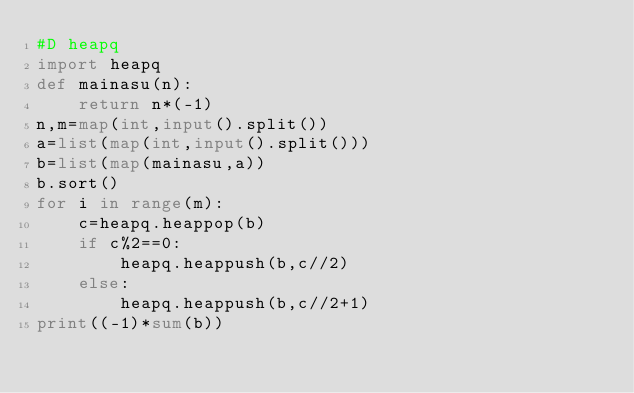<code> <loc_0><loc_0><loc_500><loc_500><_Python_>#D heapq
import heapq
def mainasu(n):
    return n*(-1)
n,m=map(int,input().split())
a=list(map(int,input().split()))
b=list(map(mainasu,a))
b.sort()
for i in range(m):
    c=heapq.heappop(b)
    if c%2==0:
        heapq.heappush(b,c//2)
    else:
        heapq.heappush(b,c//2+1)
print((-1)*sum(b))</code> 